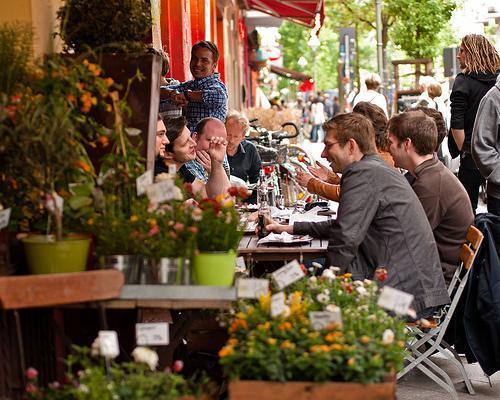How many people are wearing blue plaid?
Give a very brief answer. 2. 